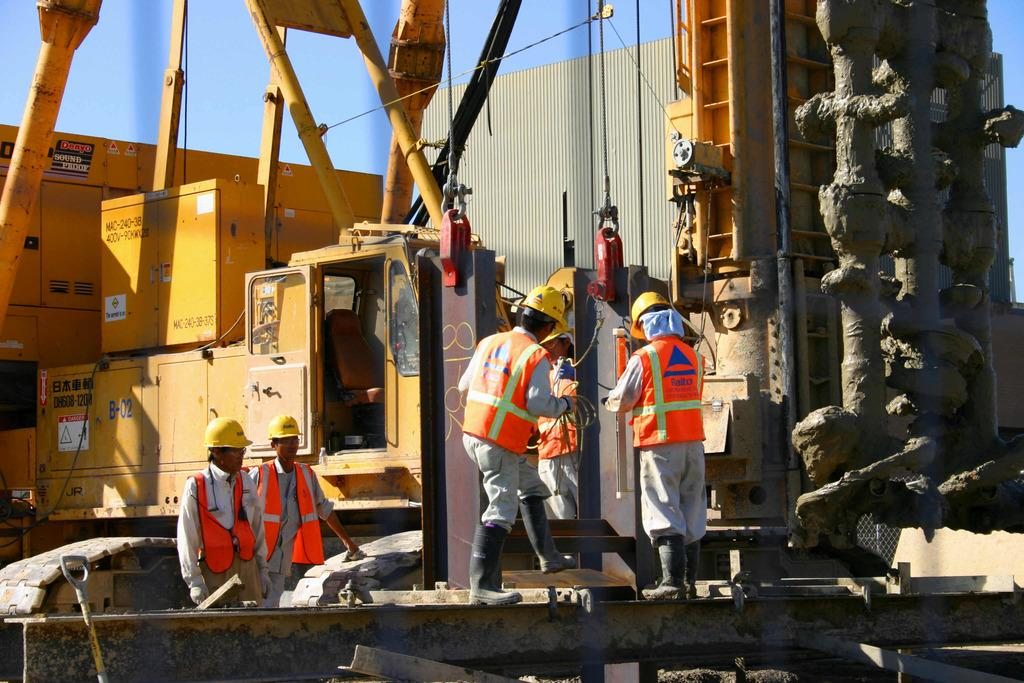What are the people in the image wearing on their heads? The people in the image are wearing helmets. What type of vehicle can be seen in the image? There is a construction vehicle in the image. What part of the natural environment is visible in the image? The sky is visible in the image. How many girls are present on the farm in the image? There is no reference to girls or a farm in the image; it features people wearing helmets and a construction vehicle. What type of writer can be seen working on their latest novel in the image? There is no writer present in the image; it features people wearing helmets and a construction vehicle. 